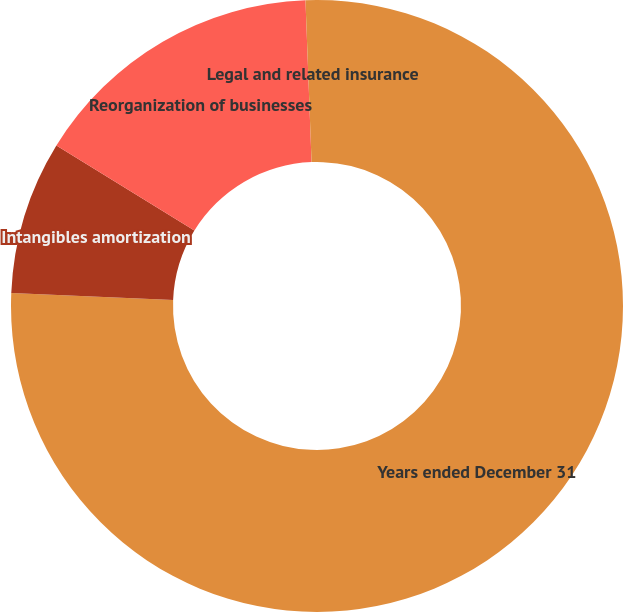Convert chart. <chart><loc_0><loc_0><loc_500><loc_500><pie_chart><fcel>Years ended December 31<fcel>Intangibles amortization<fcel>Reorganization of businesses<fcel>Legal and related insurance<nl><fcel>75.67%<fcel>8.11%<fcel>15.62%<fcel>0.6%<nl></chart> 